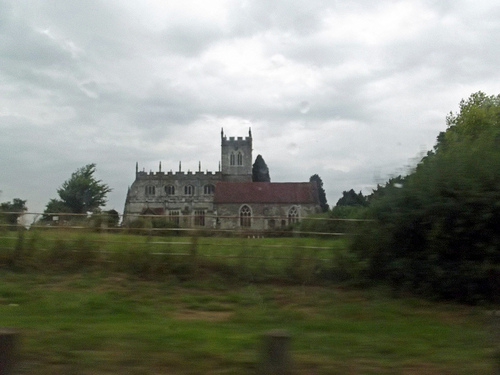<image>
Is the buliding next to the tree? Yes. The buliding is positioned adjacent to the tree, located nearby in the same general area. 